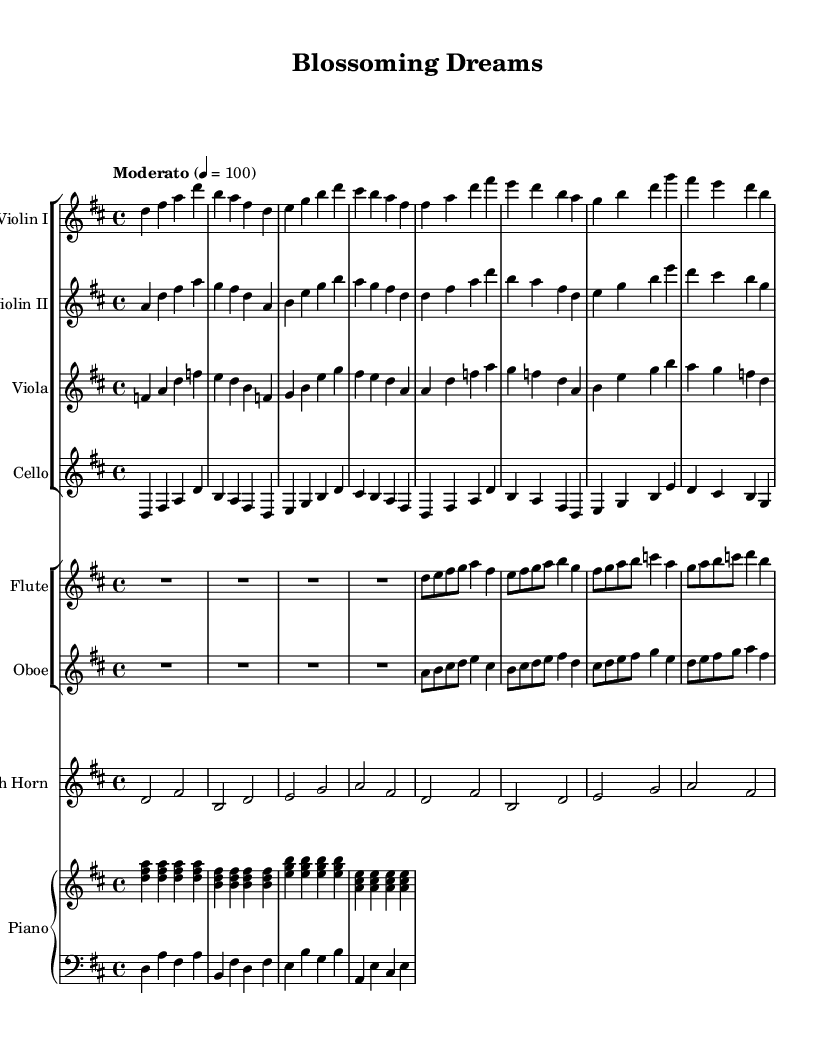What is the key signature of this music? The key signature is indicated by the sharp key signature at the beginning of the staff, which shows two sharps (F# and C#), indicating the key of D major.
Answer: D major What is the time signature of this piece? The time signature is found at the beginning of the score, labeled as 4/4, which means there are four beats in each measure and the quarter note gets one beat.
Answer: 4/4 What is the tempo marking given for this piece? The tempo marking is located at the beginning of the sheet music, stated as "Moderato" with a metronome marking of 4 = 100, indicating a moderate speed.
Answer: Moderato, 4 = 100 How many main instrument groups are present in this score? The score contains two main staff groups: one for strings (Violin I, Violin II, Viola, Cello) and another for woodwinds (Flute, Oboe) along with a French Horn and a Piano. This adds up to three groups and identifies their respective instrument types.
Answer: Three Which instruments play the melody predominantly? The melody is predominantly played by the violins and flute, as these instruments have the higher pitches and carry the main thematic elements in the score. By analyzing the scores, the first violin often leads the melodic lines, with the flute occasionally providing embellishments.
Answer: Violin I and Flute What is the rhythmic pattern of the piano accompaniment? The piano accompaniment plays a consistent rhythmic pattern, alternating between chords in the right hand and a bass line in the left hand, which maintains the harmonic structure throughout the piece. The right hand plays arpeggiated three-note chords primarily in quarter notes, establishing a steady flow.
Answer: Arpeggiated chords Are there any dynamic markings present? Yes, dynamic markings are included in the score to guide the performers on how loudly or softly to play. These markings typically indicate crescendos, decrescendos, or specific dynamics like mezzo-forte or forte. Analyzing the score reveals specific sections where these dynamics change.
Answer: Yes 